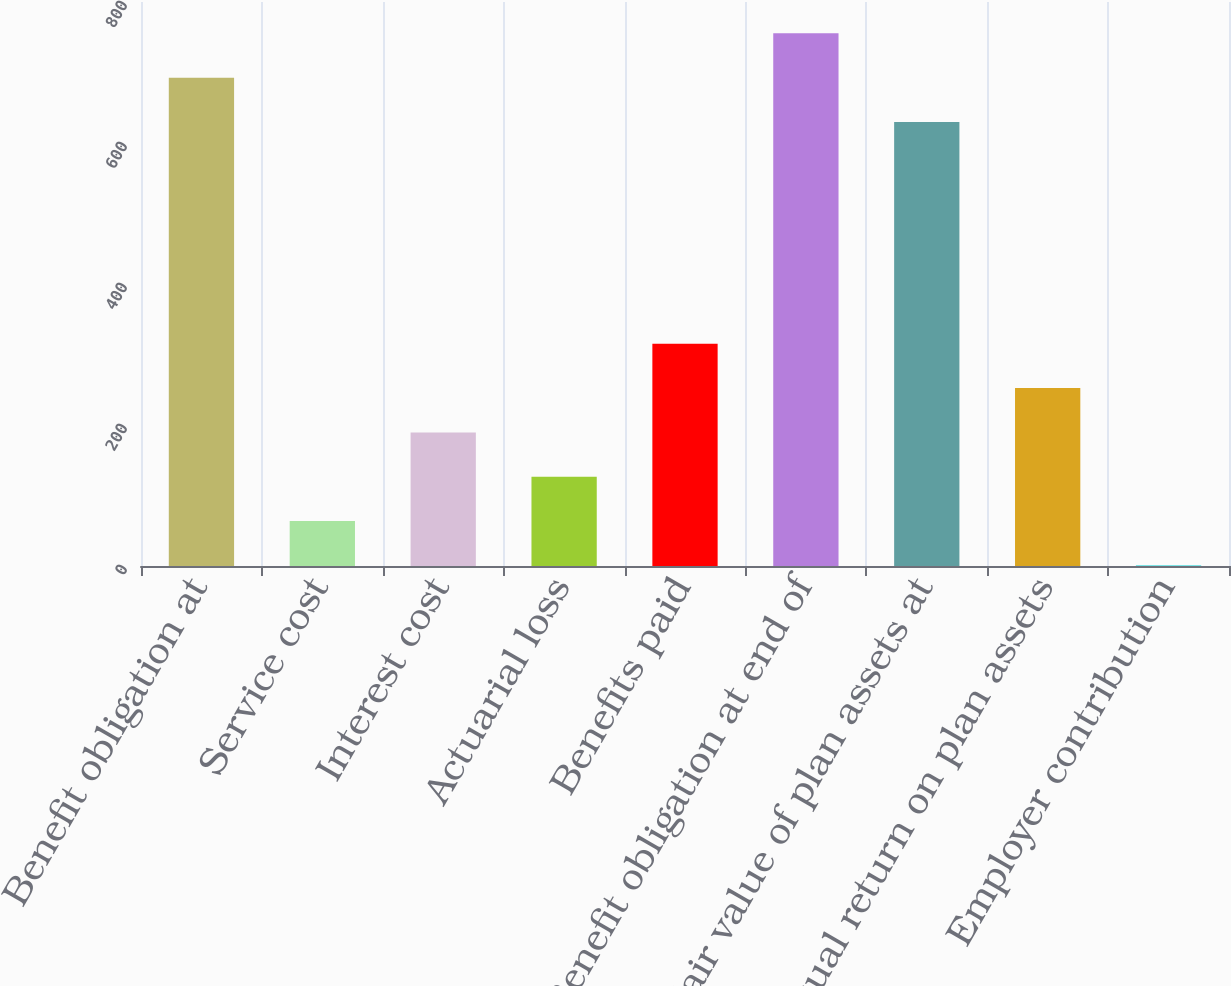Convert chart. <chart><loc_0><loc_0><loc_500><loc_500><bar_chart><fcel>Benefit obligation at<fcel>Service cost<fcel>Interest cost<fcel>Actuarial loss<fcel>Benefits paid<fcel>Benefit obligation at end of<fcel>Fair value of plan assets at<fcel>Actual return on plan assets<fcel>Employer contribution<nl><fcel>692.7<fcel>63.7<fcel>189.5<fcel>126.6<fcel>315.3<fcel>755.6<fcel>629.8<fcel>252.4<fcel>0.8<nl></chart> 